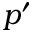<formula> <loc_0><loc_0><loc_500><loc_500>p ^ { \prime }</formula> 